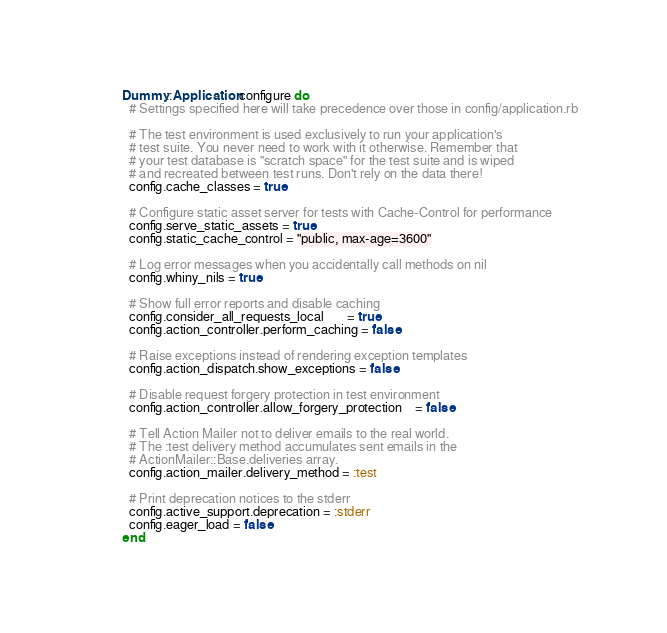Convert code to text. <code><loc_0><loc_0><loc_500><loc_500><_Ruby_>Dummy::Application.configure do
  # Settings specified here will take precedence over those in config/application.rb

  # The test environment is used exclusively to run your application's
  # test suite. You never need to work with it otherwise. Remember that
  # your test database is "scratch space" for the test suite and is wiped
  # and recreated between test runs. Don't rely on the data there!
  config.cache_classes = true

  # Configure static asset server for tests with Cache-Control for performance
  config.serve_static_assets = true
  config.static_cache_control = "public, max-age=3600"

  # Log error messages when you accidentally call methods on nil
  config.whiny_nils = true

  # Show full error reports and disable caching
  config.consider_all_requests_local       = true
  config.action_controller.perform_caching = false

  # Raise exceptions instead of rendering exception templates
  config.action_dispatch.show_exceptions = false

  # Disable request forgery protection in test environment
  config.action_controller.allow_forgery_protection    = false

  # Tell Action Mailer not to deliver emails to the real world.
  # The :test delivery method accumulates sent emails in the
  # ActionMailer::Base.deliveries array.
  config.action_mailer.delivery_method = :test

  # Print deprecation notices to the stderr
  config.active_support.deprecation = :stderr
  config.eager_load = false
end
</code> 